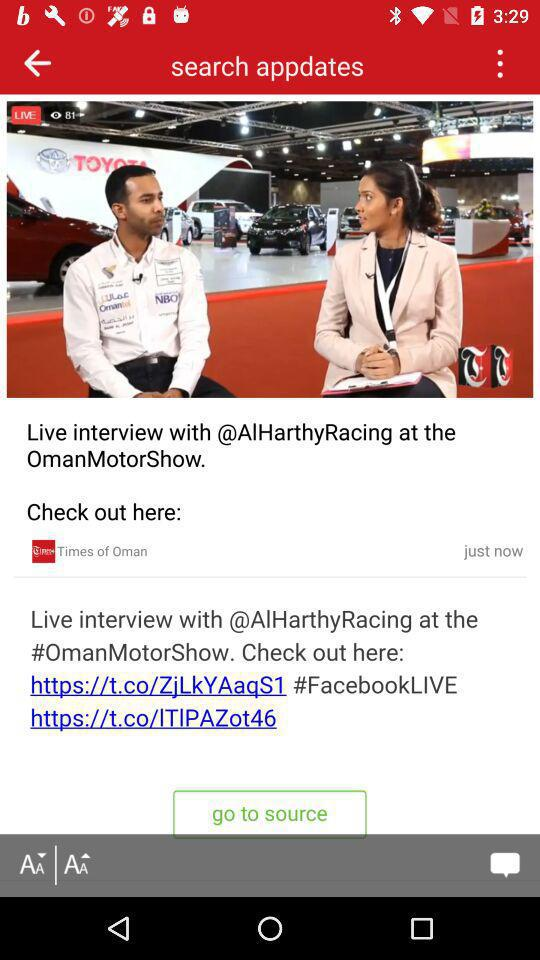What is the interview type? It is a live interview. 